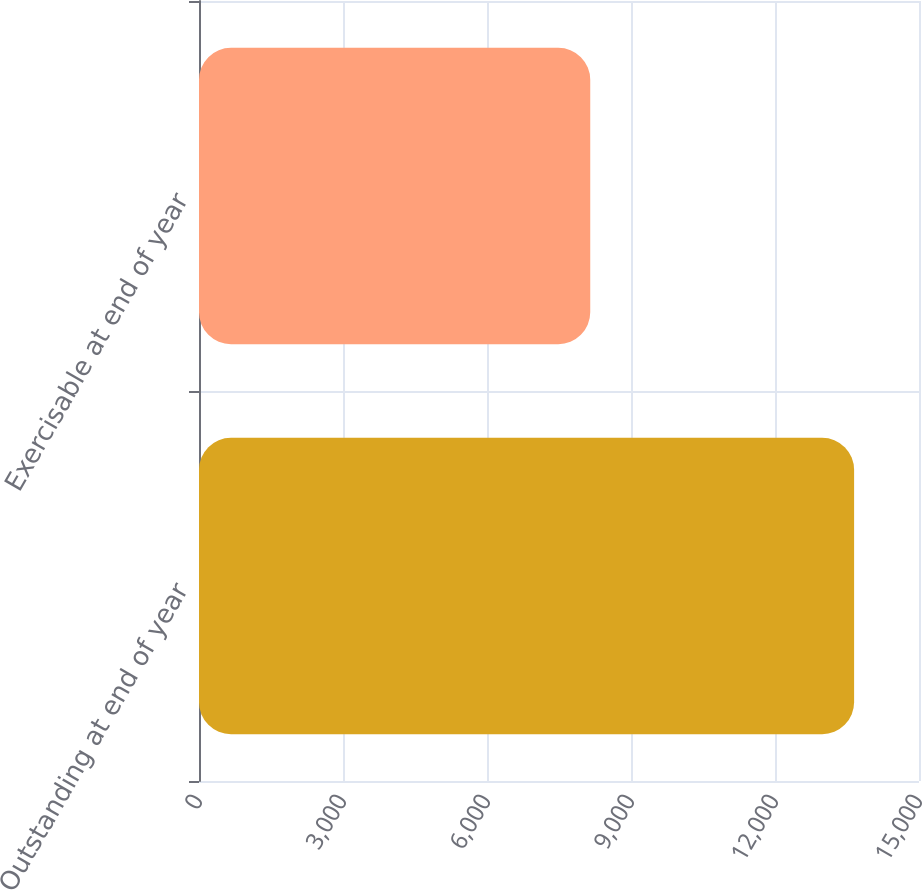<chart> <loc_0><loc_0><loc_500><loc_500><bar_chart><fcel>Outstanding at end of year<fcel>Exercisable at end of year<nl><fcel>13648<fcel>8151<nl></chart> 